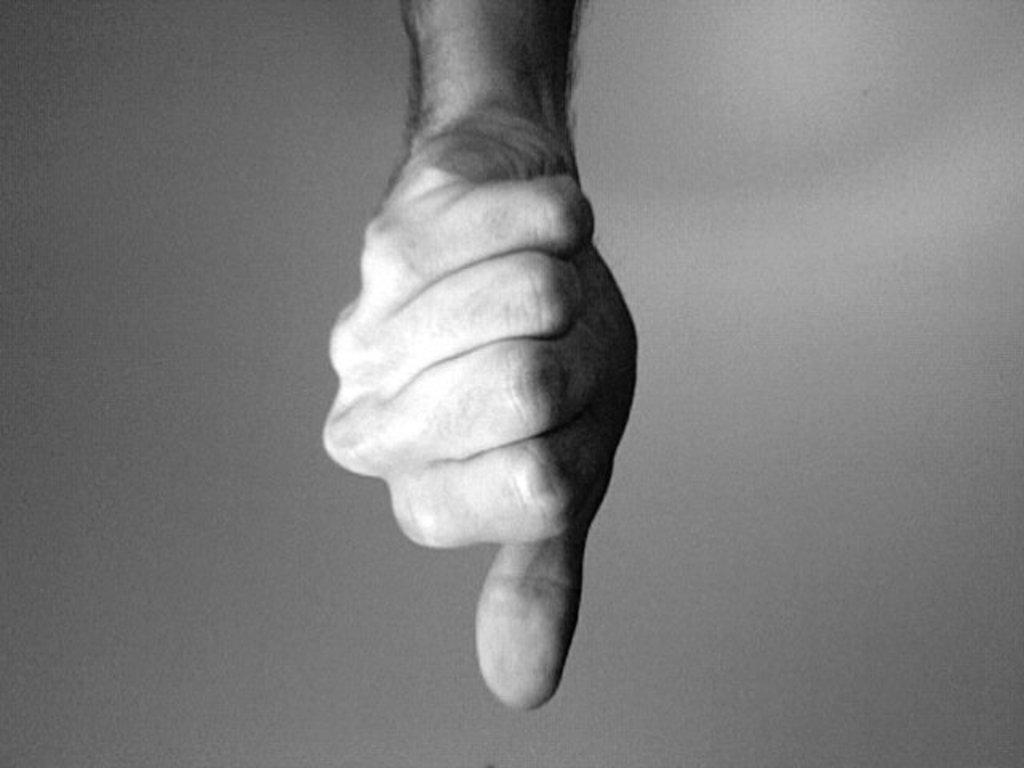What is the color scheme of the image? The image is black and white. What part of a person's body is visible in the image? There is a person's hand in the image. What gesture is the hand making? The hand is showing a thumbs down gesture. Can you see the mother and her children playing on the island in the image? There is no mother, children, or island present in the image; it only features a person's hand making a thumbs down gesture in a black and white setting. 